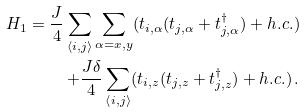Convert formula to latex. <formula><loc_0><loc_0><loc_500><loc_500>H _ { 1 } = \frac { J } { 4 } \sum _ { \left \langle i , j \right \rangle } \sum _ { \alpha = x , y } ( t _ { i , \alpha } ( t _ { j , \alpha } + t _ { j , \alpha } ^ { \dagger } ) + h . c . ) \\ + \frac { J \delta } { 4 } \sum _ { \left \langle i , j \right \rangle } ( t _ { i , z } ( t _ { j , z } + t _ { j , z } ^ { \dagger } ) + h . c . ) \, .</formula> 